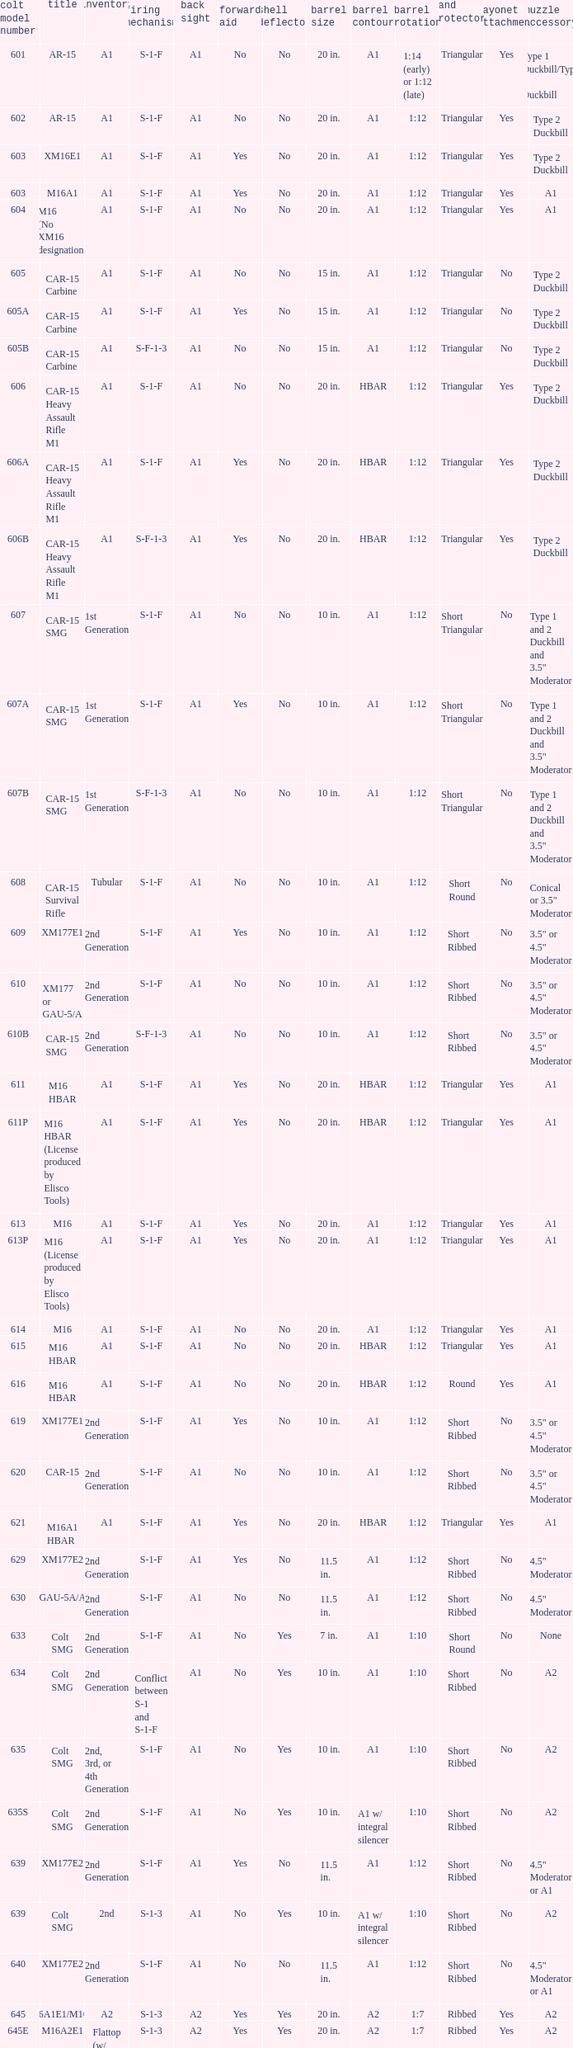What are the Colt model numbers of the models named GAU-5A/A, with no bayonet lug, no case deflector and stock of 2nd generation?  630, 649. 